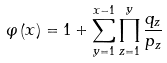Convert formula to latex. <formula><loc_0><loc_0><loc_500><loc_500>\varphi \left ( x \right ) = 1 + \sum _ { y = 1 } ^ { x - 1 } \prod _ { z = 1 } ^ { y } \frac { q _ { z } } { p _ { z } }</formula> 